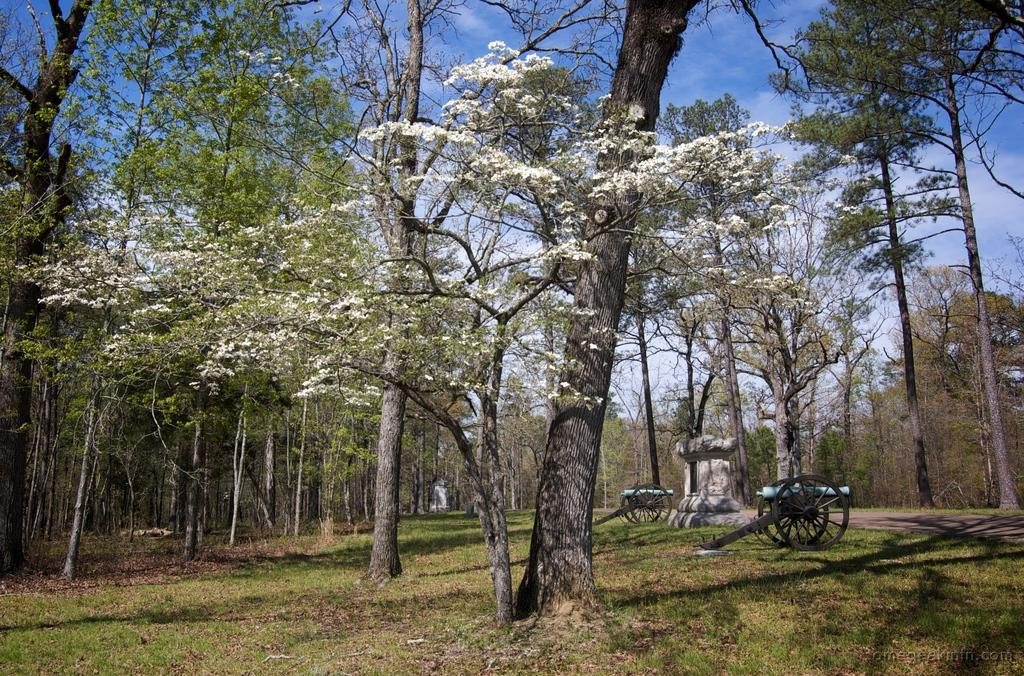What type of vegetation can be seen in the image? There are many trees in the image. What objects are present in the image that might be used for transportation? There are carts in the image. What type of ground surface is visible in the image? There is grass in the image. What type of path can be seen in the image? There is a path in the image. What type of structure can be seen in the image? There is a concrete structure in the image. What is visible in the sky in the image? The sky is visible in the image, and clouds are present. What type of music can be heard playing in the background of the image? There is no music present in the image, as it is a still photograph. How many visitors are visible in the image? There is no mention of visitors in the image, only trees, carts, grass, a path, a concrete structure, and the sky with clouds. 